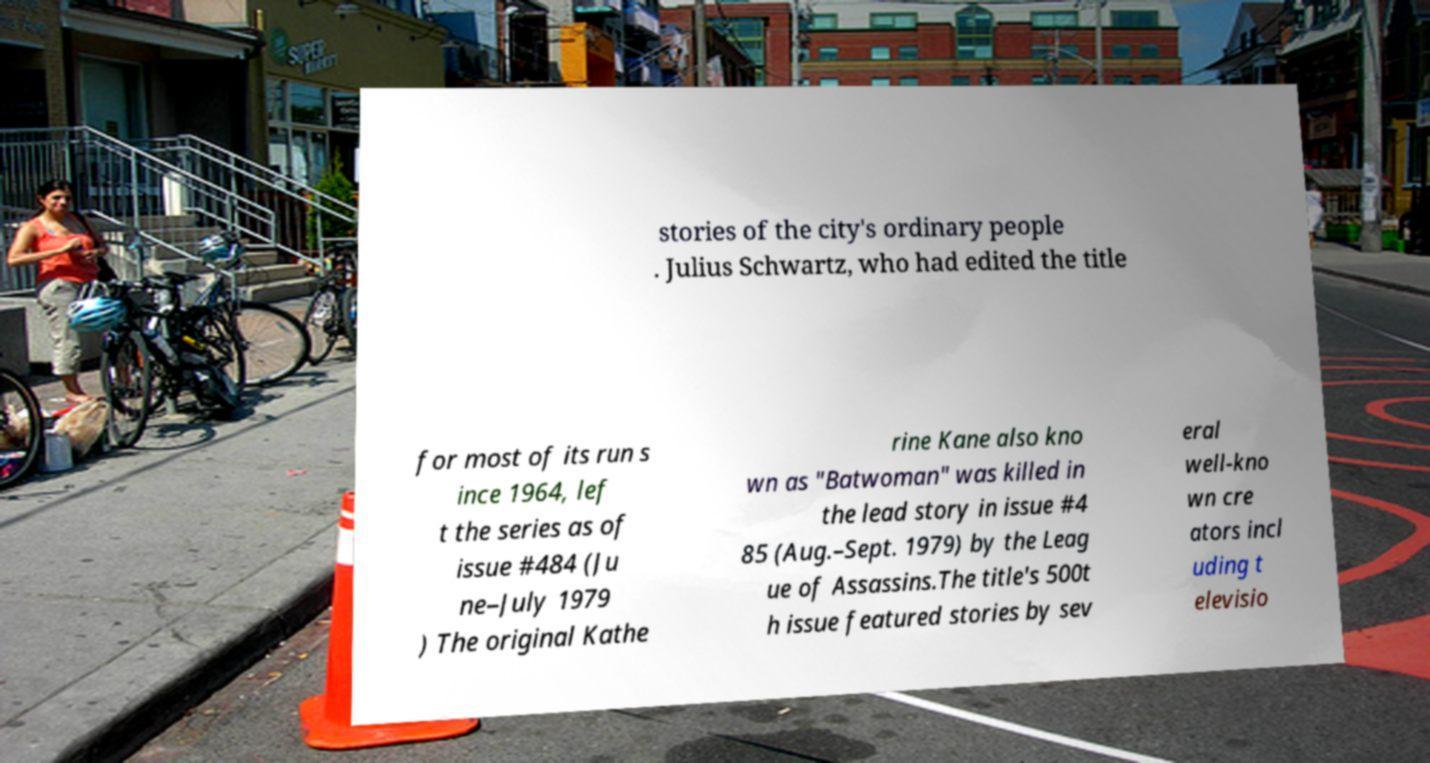Could you extract and type out the text from this image? stories of the city's ordinary people . Julius Schwartz, who had edited the title for most of its run s ince 1964, lef t the series as of issue #484 (Ju ne–July 1979 ) The original Kathe rine Kane also kno wn as "Batwoman" was killed in the lead story in issue #4 85 (Aug.–Sept. 1979) by the Leag ue of Assassins.The title's 500t h issue featured stories by sev eral well-kno wn cre ators incl uding t elevisio 